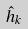Convert formula to latex. <formula><loc_0><loc_0><loc_500><loc_500>\hat { h } _ { k }</formula> 